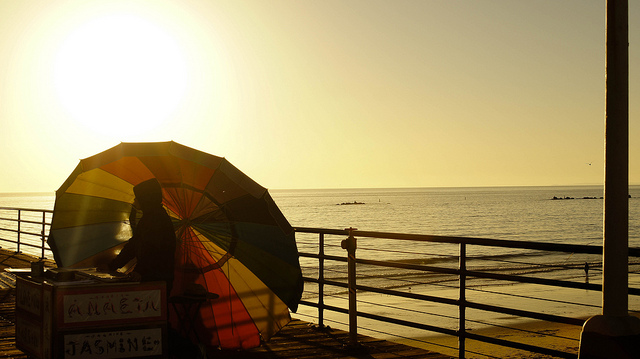Please identify all text content in this image. AMAETH JASMINE 